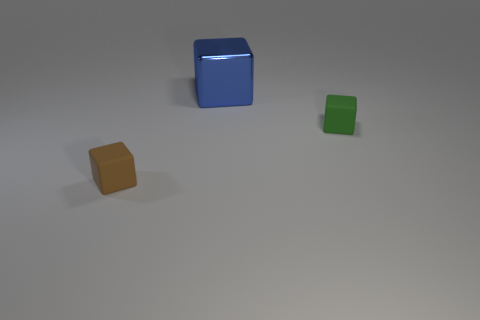Add 2 brown cubes. How many objects exist? 5 Add 2 big blue blocks. How many big blue blocks are left? 3 Add 2 purple cylinders. How many purple cylinders exist? 2 Subtract 0 red cylinders. How many objects are left? 3 Subtract all large blue shiny objects. Subtract all large brown metal spheres. How many objects are left? 2 